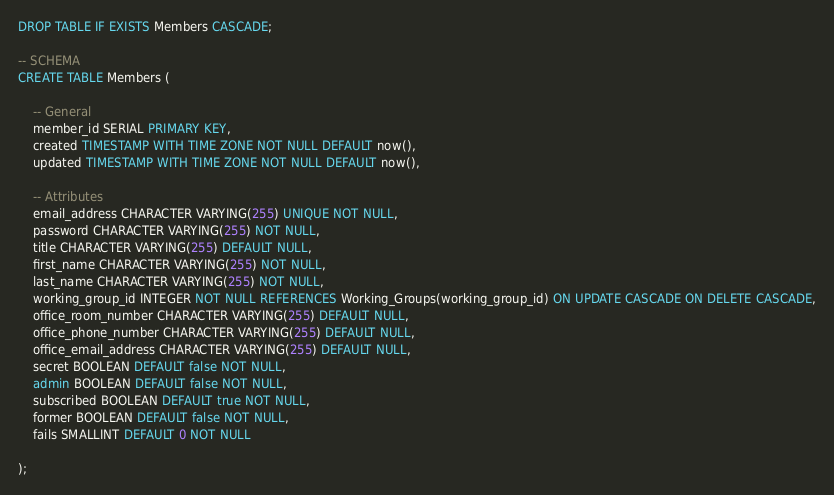Convert code to text. <code><loc_0><loc_0><loc_500><loc_500><_SQL_>DROP TABLE IF EXISTS Members CASCADE;

-- SCHEMA
CREATE TABLE Members (

    -- General
    member_id SERIAL PRIMARY KEY,
    created TIMESTAMP WITH TIME ZONE NOT NULL DEFAULT now(),
    updated TIMESTAMP WITH TIME ZONE NOT NULL DEFAULT now(),

    -- Attributes
    email_address CHARACTER VARYING(255) UNIQUE NOT NULL,
    password CHARACTER VARYING(255) NOT NULL,
    title CHARACTER VARYING(255) DEFAULT NULL,
    first_name CHARACTER VARYING(255) NOT NULL,
    last_name CHARACTER VARYING(255) NOT NULL,
    working_group_id INTEGER NOT NULL REFERENCES Working_Groups(working_group_id) ON UPDATE CASCADE ON DELETE CASCADE,
    office_room_number CHARACTER VARYING(255) DEFAULT NULL,
    office_phone_number CHARACTER VARYING(255) DEFAULT NULL,
    office_email_address CHARACTER VARYING(255) DEFAULT NULL,
    secret BOOLEAN DEFAULT false NOT NULL,
    admin BOOLEAN DEFAULT false NOT NULL,
    subscribed BOOLEAN DEFAULT true NOT NULL,
    former BOOLEAN DEFAULT false NOT NULL,
    fails SMALLINT DEFAULT 0 NOT NULL

);
</code> 